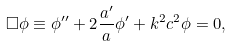Convert formula to latex. <formula><loc_0><loc_0><loc_500><loc_500>\Box \phi \equiv \phi ^ { \prime \prime } + 2 \frac { a ^ { \prime } } { a } \phi ^ { \prime } + k ^ { 2 } c ^ { 2 } \phi = 0 ,</formula> 